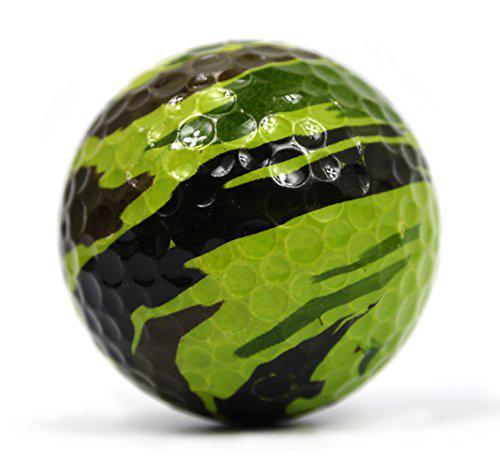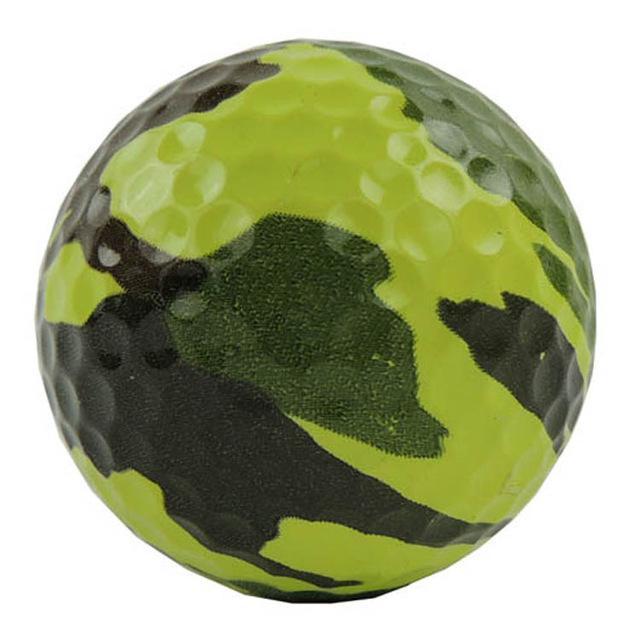The first image is the image on the left, the second image is the image on the right. Analyze the images presented: Is the assertion "The image on the right includes a box of three camo patterned golf balls, and the image on the left includes a group of three balls that are not in a package." valid? Answer yes or no. No. The first image is the image on the left, the second image is the image on the right. Given the left and right images, does the statement "The left and right image contains the same number of combat golf balls." hold true? Answer yes or no. Yes. 